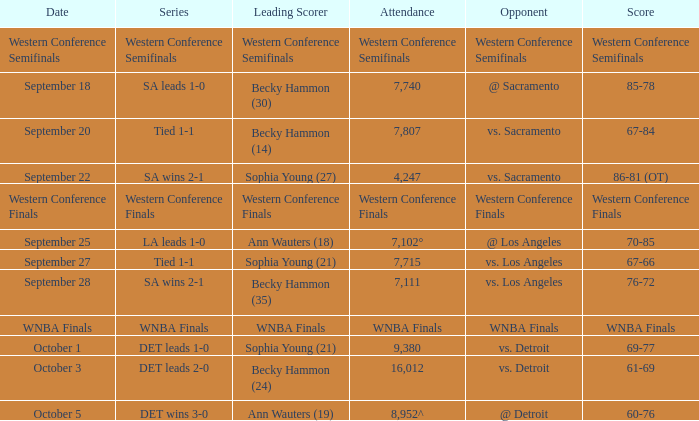Could you parse the entire table? {'header': ['Date', 'Series', 'Leading Scorer', 'Attendance', 'Opponent', 'Score'], 'rows': [['Western Conference Semifinals', 'Western Conference Semifinals', 'Western Conference Semifinals', 'Western Conference Semifinals', 'Western Conference Semifinals', 'Western Conference Semifinals'], ['September 18', 'SA leads 1-0', 'Becky Hammon (30)', '7,740', '@ Sacramento', '85-78'], ['September 20', 'Tied 1-1', 'Becky Hammon (14)', '7,807', 'vs. Sacramento', '67-84'], ['September 22', 'SA wins 2-1', 'Sophia Young (27)', '4,247', 'vs. Sacramento', '86-81 (OT)'], ['Western Conference Finals', 'Western Conference Finals', 'Western Conference Finals', 'Western Conference Finals', 'Western Conference Finals', 'Western Conference Finals'], ['September 25', 'LA leads 1-0', 'Ann Wauters (18)', '7,102°', '@ Los Angeles', '70-85'], ['September 27', 'Tied 1-1', 'Sophia Young (21)', '7,715', 'vs. Los Angeles', '67-66'], ['September 28', 'SA wins 2-1', 'Becky Hammon (35)', '7,111', 'vs. Los Angeles', '76-72'], ['WNBA Finals', 'WNBA Finals', 'WNBA Finals', 'WNBA Finals', 'WNBA Finals', 'WNBA Finals'], ['October 1', 'DET leads 1-0', 'Sophia Young (21)', '9,380', 'vs. Detroit', '69-77'], ['October 3', 'DET leads 2-0', 'Becky Hammon (24)', '16,012', 'vs. Detroit', '61-69'], ['October 5', 'DET wins 3-0', 'Ann Wauters (19)', '8,952^', '@ Detroit', '60-76']]} Who is the opponent of the game with a tied 1-1 series and becky hammon (14) as the leading scorer? Vs. sacramento. 